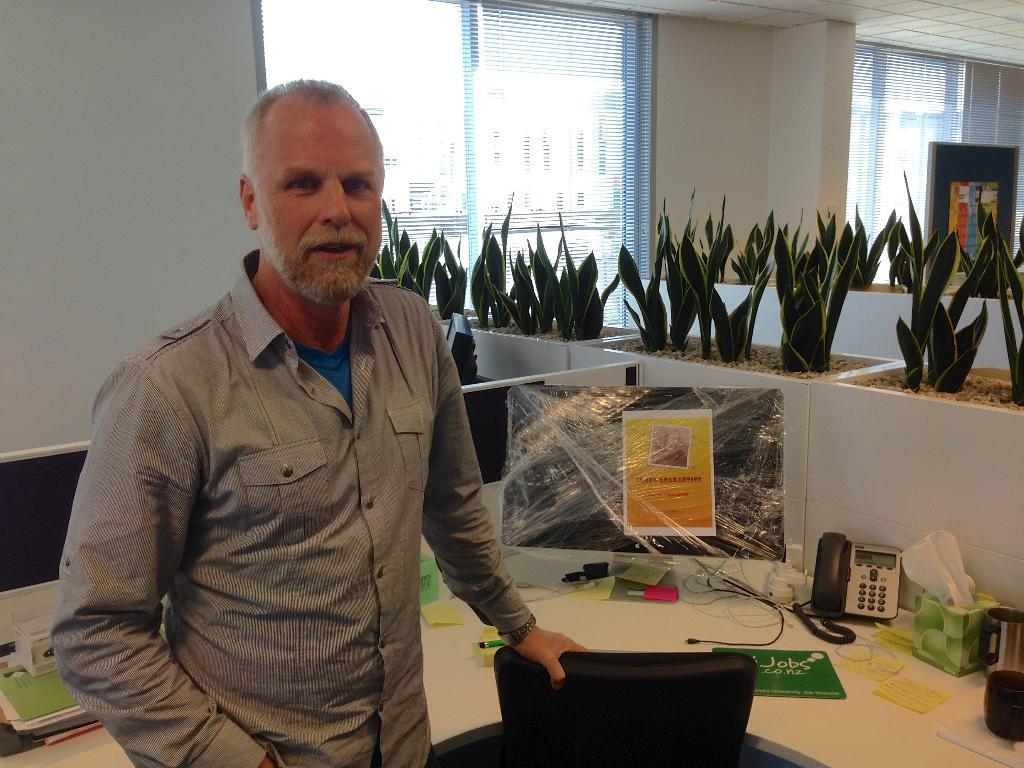Please provide a concise description of this image. In this picture we can see a man. This is chair and there is a table. On the table there is a monitor, phone, and books. These are the plants. On the background there is a wall and this is window. 